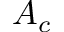<formula> <loc_0><loc_0><loc_500><loc_500>A _ { c }</formula> 